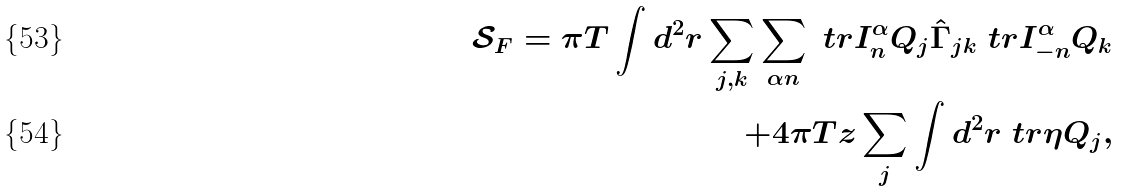Convert formula to latex. <formula><loc_0><loc_0><loc_500><loc_500>\mathcal { S } _ { F } = \pi T \int d ^ { 2 } r \sum _ { j , k } \sum _ { \alpha n } \ t r I _ { n } ^ { \alpha } Q _ { j } \hat { \Gamma } _ { j k } \ t r I _ { - n } ^ { \alpha } Q _ { k } \\ + 4 \pi T z \sum _ { j } \int d ^ { 2 } r \ t r \eta Q _ { j } ,</formula> 